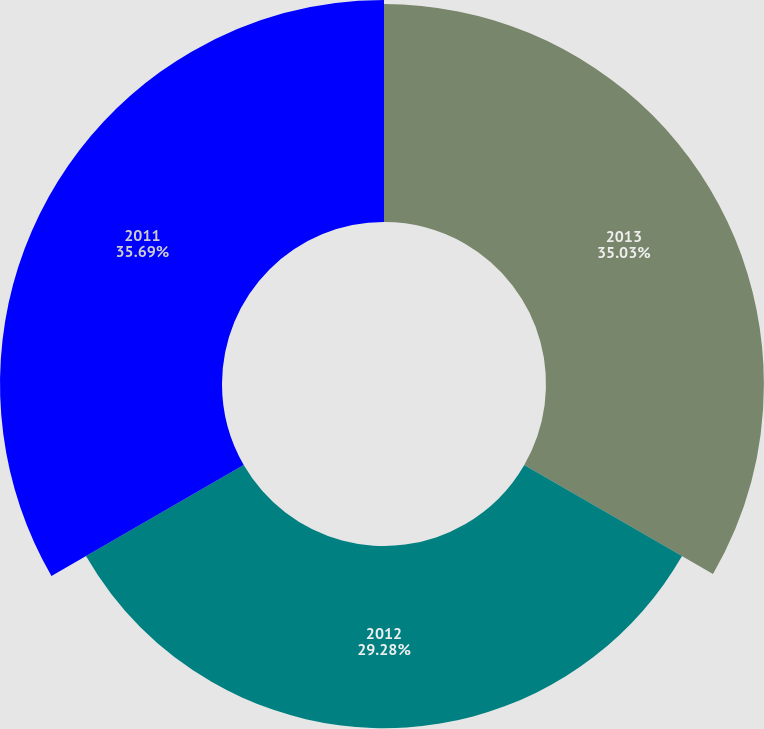Convert chart. <chart><loc_0><loc_0><loc_500><loc_500><pie_chart><fcel>2013<fcel>2012<fcel>2011<nl><fcel>35.03%<fcel>29.28%<fcel>35.69%<nl></chart> 